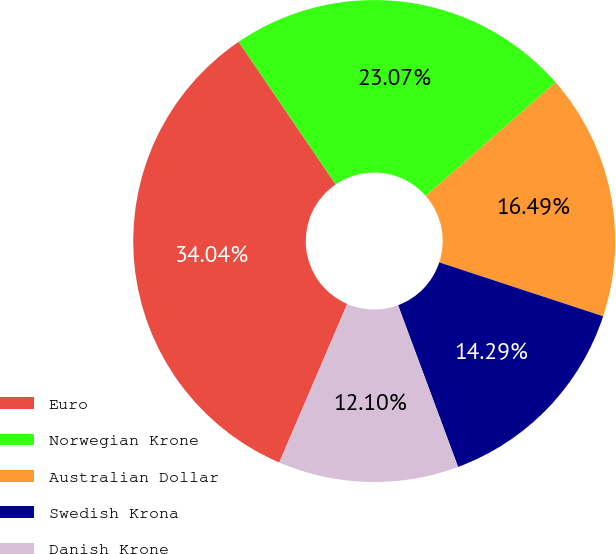Convert chart to OTSL. <chart><loc_0><loc_0><loc_500><loc_500><pie_chart><fcel>Euro<fcel>Norwegian Krone<fcel>Australian Dollar<fcel>Swedish Krona<fcel>Danish Krone<nl><fcel>34.04%<fcel>23.07%<fcel>16.49%<fcel>14.29%<fcel>12.1%<nl></chart> 